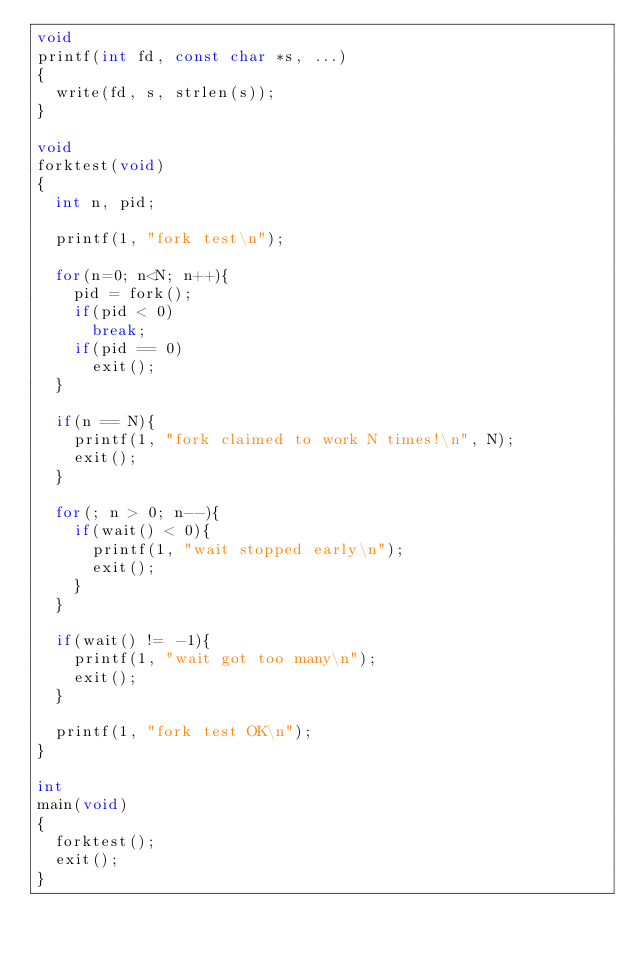Convert code to text. <code><loc_0><loc_0><loc_500><loc_500><_C_>void
printf(int fd, const char *s, ...)
{
  write(fd, s, strlen(s));
}

void
forktest(void)
{
  int n, pid;

  printf(1, "fork test\n");

  for(n=0; n<N; n++){
    pid = fork();
    if(pid < 0)
      break;
    if(pid == 0)
      exit();
  }

  if(n == N){
    printf(1, "fork claimed to work N times!\n", N);
    exit();
  }

  for(; n > 0; n--){
    if(wait() < 0){
      printf(1, "wait stopped early\n");
      exit();
    }
  }

  if(wait() != -1){
    printf(1, "wait got too many\n");
    exit();
  }

  printf(1, "fork test OK\n");
}

int
main(void)
{
  forktest();
  exit();
}
</code> 